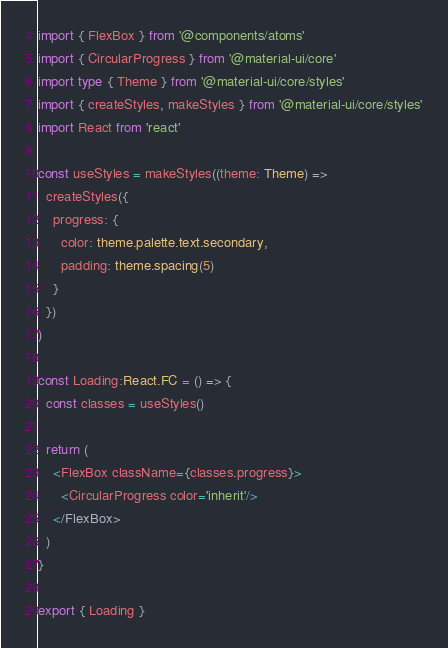Convert code to text. <code><loc_0><loc_0><loc_500><loc_500><_TypeScript_>import { FlexBox } from '@components/atoms'
import { CircularProgress } from '@material-ui/core'
import type { Theme } from '@material-ui/core/styles'
import { createStyles, makeStyles } from '@material-ui/core/styles'
import React from 'react'

const useStyles = makeStyles((theme: Theme) =>
  createStyles({
    progress: {
      color: theme.palette.text.secondary,
      padding: theme.spacing(5)
    }
  })
)

const Loading:React.FC = () => {
  const classes = useStyles()

  return (
    <FlexBox className={classes.progress}>
      <CircularProgress color='inherit'/>
    </FlexBox>
  )
}

export { Loading }
</code> 